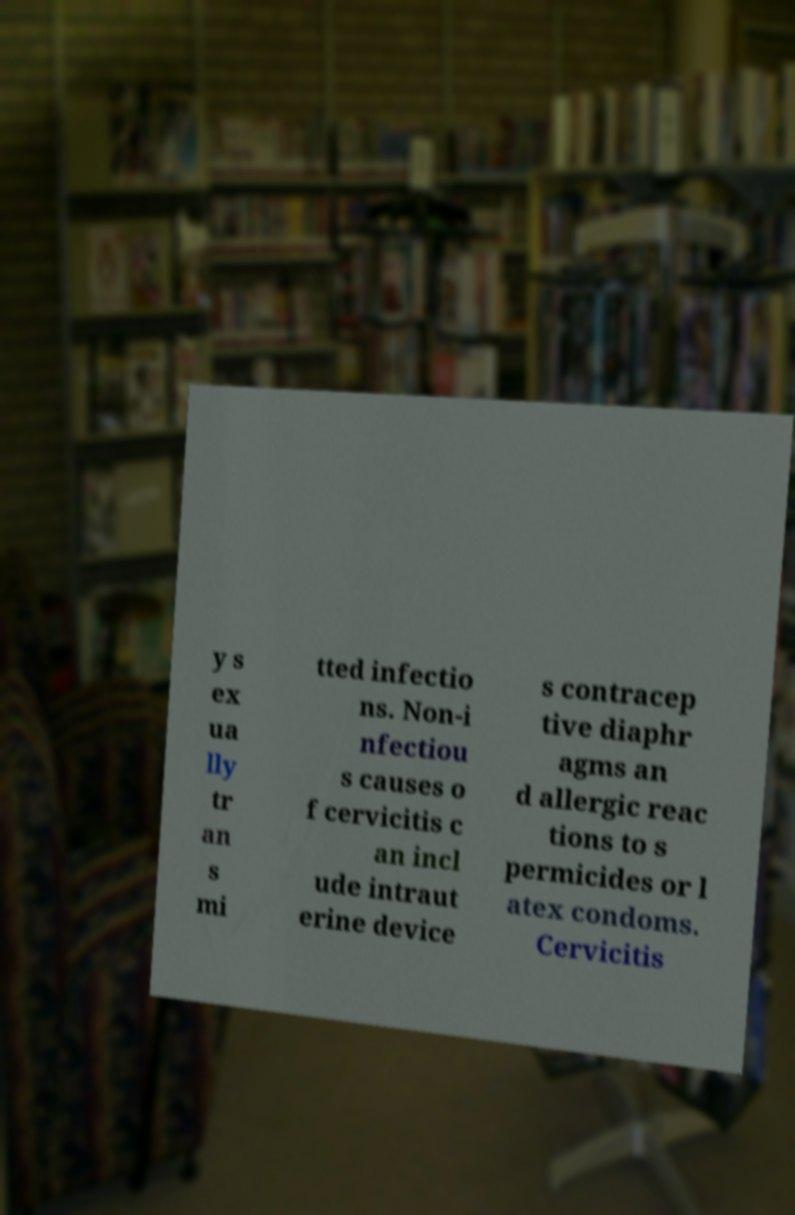Could you assist in decoding the text presented in this image and type it out clearly? y s ex ua lly tr an s mi tted infectio ns. Non-i nfectiou s causes o f cervicitis c an incl ude intraut erine device s contracep tive diaphr agms an d allergic reac tions to s permicides or l atex condoms. Cervicitis 